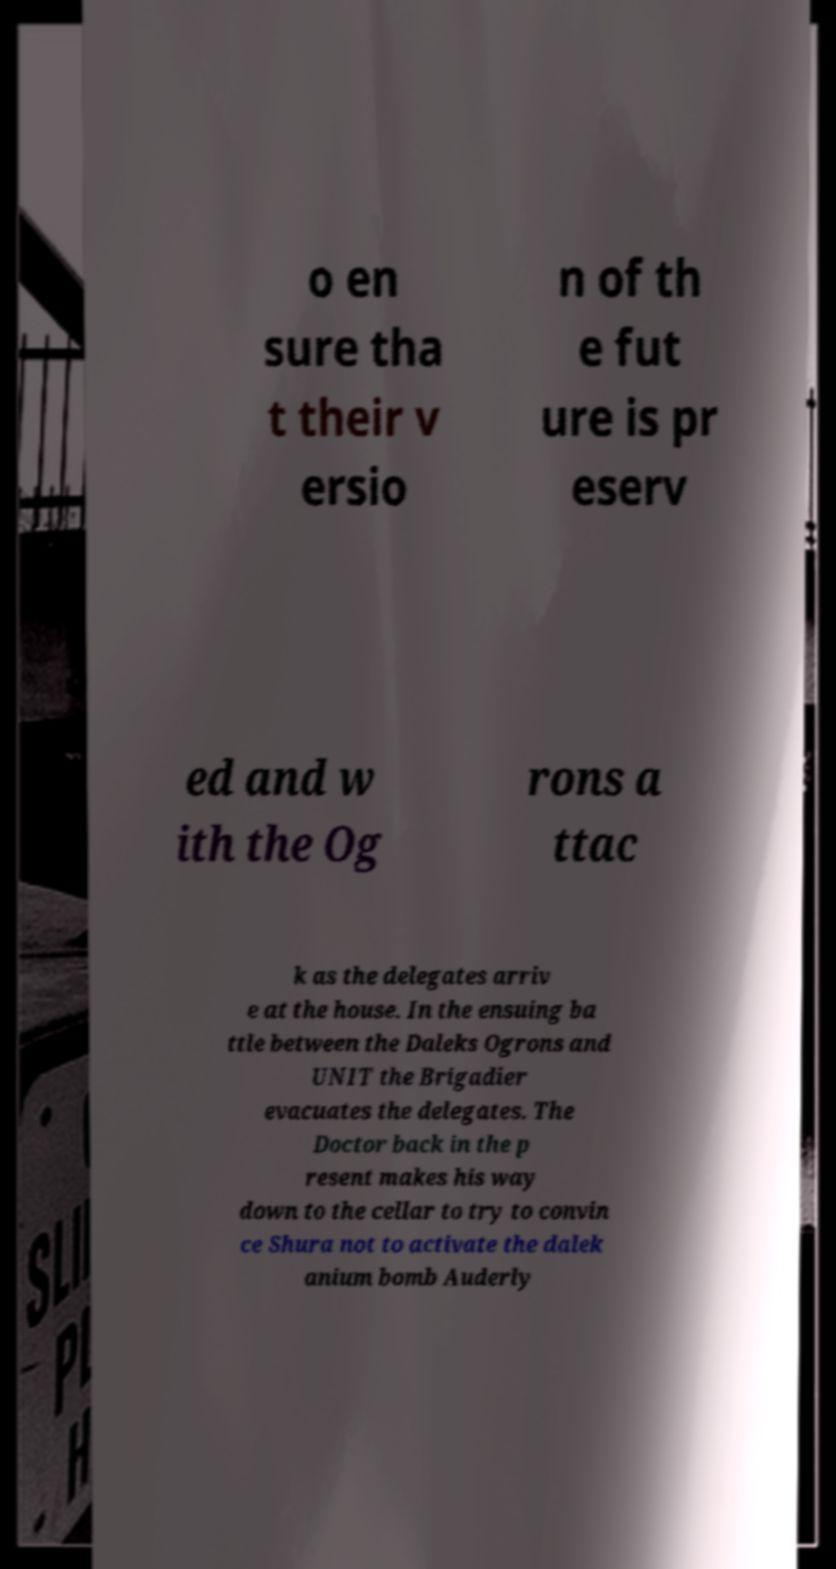There's text embedded in this image that I need extracted. Can you transcribe it verbatim? o en sure tha t their v ersio n of th e fut ure is pr eserv ed and w ith the Og rons a ttac k as the delegates arriv e at the house. In the ensuing ba ttle between the Daleks Ogrons and UNIT the Brigadier evacuates the delegates. The Doctor back in the p resent makes his way down to the cellar to try to convin ce Shura not to activate the dalek anium bomb Auderly 